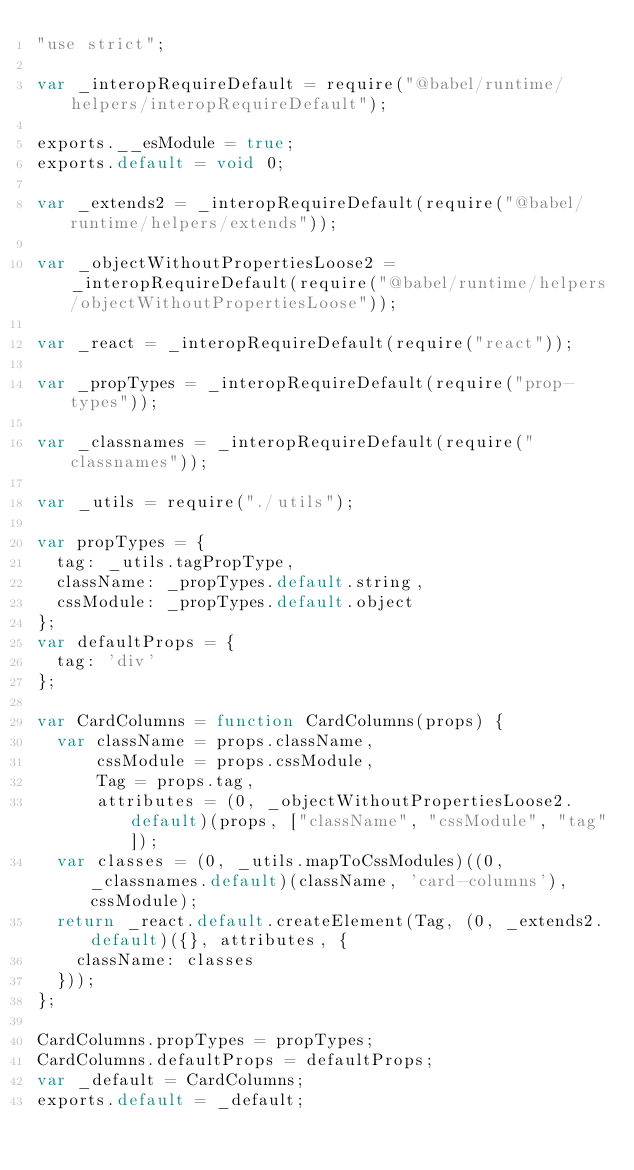<code> <loc_0><loc_0><loc_500><loc_500><_JavaScript_>"use strict";

var _interopRequireDefault = require("@babel/runtime/helpers/interopRequireDefault");

exports.__esModule = true;
exports.default = void 0;

var _extends2 = _interopRequireDefault(require("@babel/runtime/helpers/extends"));

var _objectWithoutPropertiesLoose2 = _interopRequireDefault(require("@babel/runtime/helpers/objectWithoutPropertiesLoose"));

var _react = _interopRequireDefault(require("react"));

var _propTypes = _interopRequireDefault(require("prop-types"));

var _classnames = _interopRequireDefault(require("classnames"));

var _utils = require("./utils");

var propTypes = {
  tag: _utils.tagPropType,
  className: _propTypes.default.string,
  cssModule: _propTypes.default.object
};
var defaultProps = {
  tag: 'div'
};

var CardColumns = function CardColumns(props) {
  var className = props.className,
      cssModule = props.cssModule,
      Tag = props.tag,
      attributes = (0, _objectWithoutPropertiesLoose2.default)(props, ["className", "cssModule", "tag"]);
  var classes = (0, _utils.mapToCssModules)((0, _classnames.default)(className, 'card-columns'), cssModule);
  return _react.default.createElement(Tag, (0, _extends2.default)({}, attributes, {
    className: classes
  }));
};

CardColumns.propTypes = propTypes;
CardColumns.defaultProps = defaultProps;
var _default = CardColumns;
exports.default = _default;</code> 